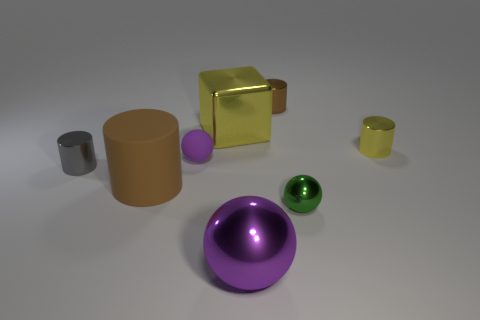Is there anything else that has the same color as the block?
Offer a terse response. Yes. The tiny metallic thing that is behind the big metallic block has what shape?
Your response must be concise. Cylinder. Does the big shiny cube have the same color as the tiny thing that is right of the green ball?
Provide a short and direct response. Yes. Is the number of tiny purple rubber things that are on the left side of the gray cylinder the same as the number of blocks behind the large sphere?
Your answer should be compact. No. How many other things are there of the same size as the gray object?
Give a very brief answer. 4. What size is the purple rubber ball?
Provide a short and direct response. Small. Does the cube have the same material as the brown thing in front of the small gray cylinder?
Your answer should be compact. No. Is there a purple rubber object that has the same shape as the big purple metal object?
Provide a succinct answer. Yes. What material is the cylinder that is the same size as the yellow shiny block?
Offer a terse response. Rubber. There is a yellow thing on the right side of the green metallic thing; how big is it?
Keep it short and to the point. Small. 